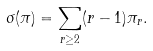Convert formula to latex. <formula><loc_0><loc_0><loc_500><loc_500>\sigma ( \pi ) = \sum _ { r \geq 2 } ( r - 1 ) \pi _ { r } .</formula> 